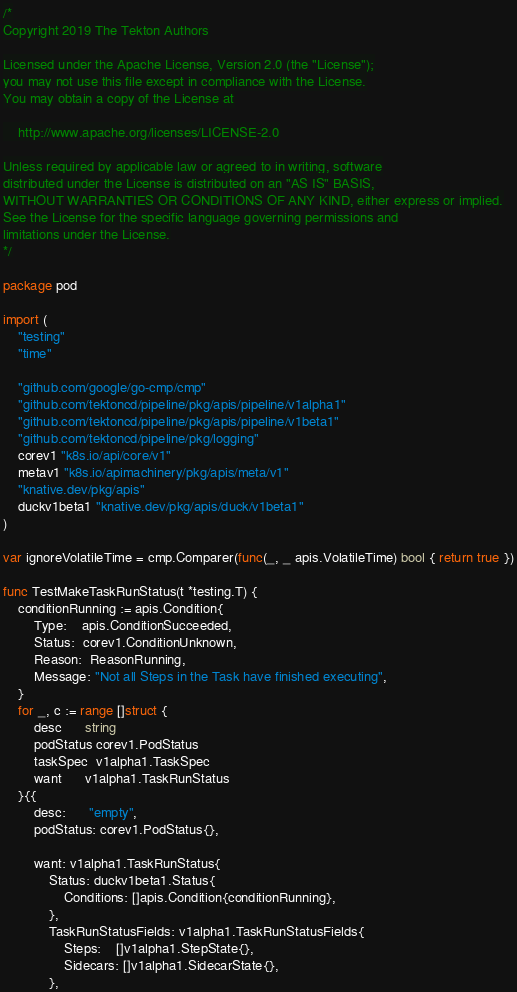Convert code to text. <code><loc_0><loc_0><loc_500><loc_500><_Go_>/*
Copyright 2019 The Tekton Authors

Licensed under the Apache License, Version 2.0 (the "License");
you may not use this file except in compliance with the License.
You may obtain a copy of the License at

    http://www.apache.org/licenses/LICENSE-2.0

Unless required by applicable law or agreed to in writing, software
distributed under the License is distributed on an "AS IS" BASIS,
WITHOUT WARRANTIES OR CONDITIONS OF ANY KIND, either express or implied.
See the License for the specific language governing permissions and
limitations under the License.
*/

package pod

import (
	"testing"
	"time"

	"github.com/google/go-cmp/cmp"
	"github.com/tektoncd/pipeline/pkg/apis/pipeline/v1alpha1"
	"github.com/tektoncd/pipeline/pkg/apis/pipeline/v1beta1"
	"github.com/tektoncd/pipeline/pkg/logging"
	corev1 "k8s.io/api/core/v1"
	metav1 "k8s.io/apimachinery/pkg/apis/meta/v1"
	"knative.dev/pkg/apis"
	duckv1beta1 "knative.dev/pkg/apis/duck/v1beta1"
)

var ignoreVolatileTime = cmp.Comparer(func(_, _ apis.VolatileTime) bool { return true })

func TestMakeTaskRunStatus(t *testing.T) {
	conditionRunning := apis.Condition{
		Type:    apis.ConditionSucceeded,
		Status:  corev1.ConditionUnknown,
		Reason:  ReasonRunning,
		Message: "Not all Steps in the Task have finished executing",
	}
	for _, c := range []struct {
		desc      string
		podStatus corev1.PodStatus
		taskSpec  v1alpha1.TaskSpec
		want      v1alpha1.TaskRunStatus
	}{{
		desc:      "empty",
		podStatus: corev1.PodStatus{},

		want: v1alpha1.TaskRunStatus{
			Status: duckv1beta1.Status{
				Conditions: []apis.Condition{conditionRunning},
			},
			TaskRunStatusFields: v1alpha1.TaskRunStatusFields{
				Steps:    []v1alpha1.StepState{},
				Sidecars: []v1alpha1.SidecarState{},
			},</code> 